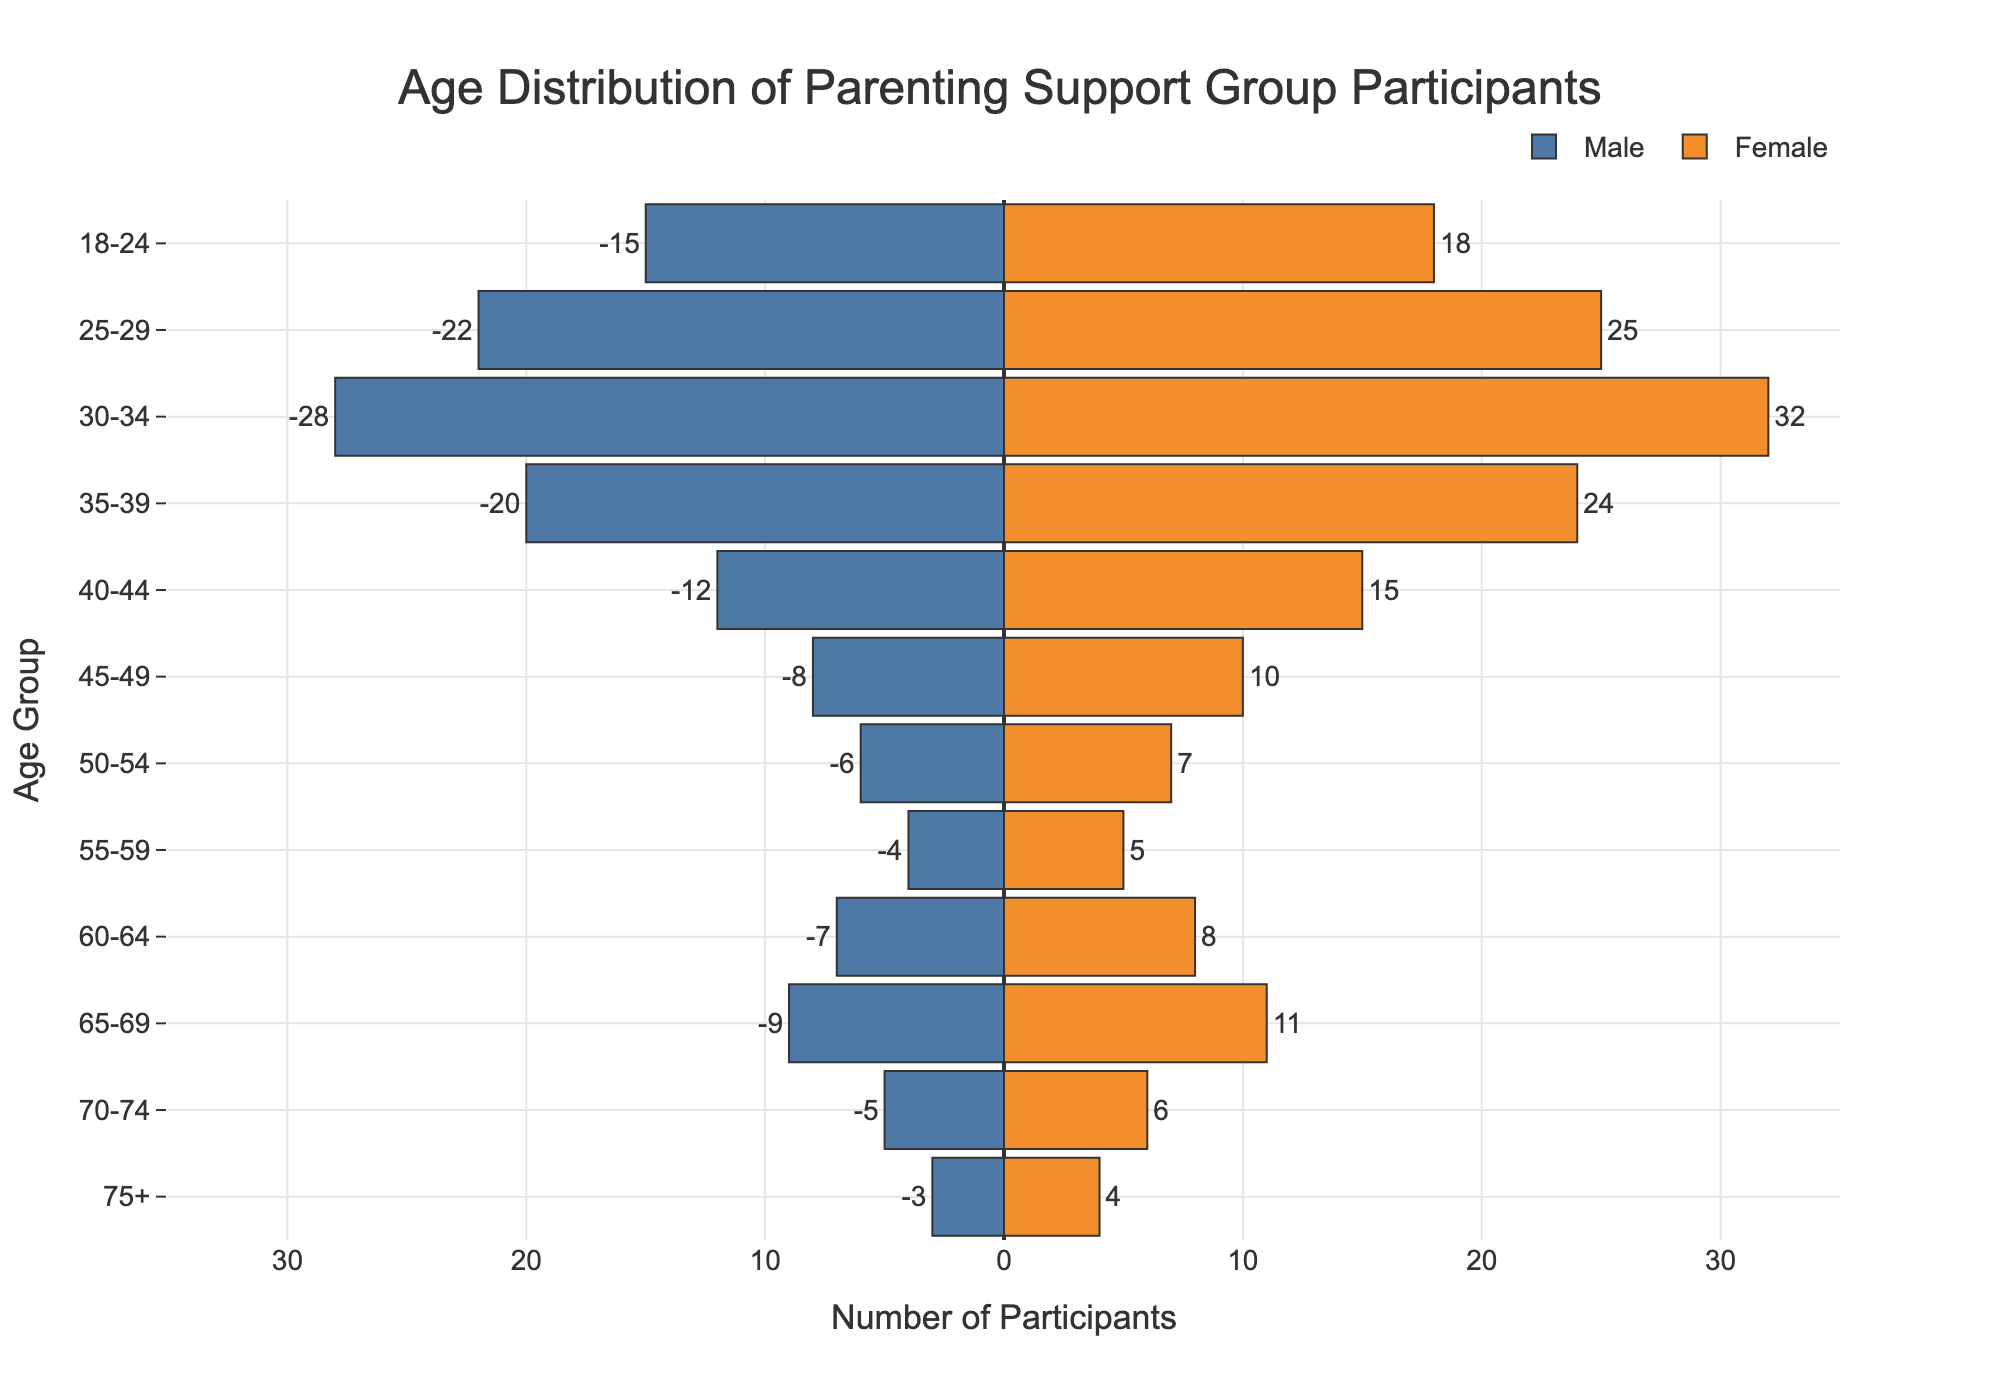What is the title of the chart? The title is displayed at the top center of the chart. It reads "Age Distribution of Parenting Support Group Participants".
Answer: Age Distribution of Parenting Support Group Participants What is the age group with the highest number of female participants? Look at the age groups listed on the y-axis and compare the bar lengths for female participants. The age group 30-34 has the longest bar for females.
Answer: 30-34 How many male participants are there in the 25-29 age group? Look at the horizontal bar for the 25-29 age group on the left side of the pyramid. The label outside the bar indicates -22, which represents 22 male participants.
Answer: 22 Which age group has more males than females? Compare the lengths of the bars for males and females for each age group. The 60-64 age group has more male participants (7) than female participants (8).
Answer: None What are the total male participants in the group? Add up all the male participants from each age group: 15 + 22 + 28 + 20 + 12 + 8 + 6 + 4 + 7 + 9 + 5 + 3 = 139.
Answer: 139 What is the smallest number of participants in a single age group? Examine all bars and their labels. The smallest number is 3 male participants in the 75+ age group.
Answer: 3 What is the gender ratio in the 35-39 age group? For the 35-39 age group, there are 24 females and 20 males. The ratio of males to females is 20/24, which simplifies to 5/6.
Answer: 5/6 Which age group has the narrowest gap in the number of participants between males and females? Compare the difference in bar lengths for each age group. The difference for the 55-59 age group is minimal, with 4 males and 5 females (a gap of 1).
Answer: 55-59 How many more females are there than males in the 40-44 age group? Subtract the number of males in the 40-44 age group (12) from the number of females (15). The difference is 15 - 12 = 3.
Answer: 3 What is the largest age group among participants who are 60+ years old? Compare the lengths of bars for age groups 60-64, 65-69, 70-74, and 75+. The 65-69 age group has the longest combined bar for males and females, totaling 20 participants (9 males + 11 females).
Answer: 65-69 